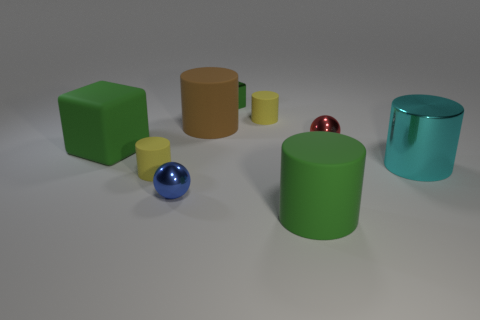Subtract all brown matte cylinders. How many cylinders are left? 4 Subtract all cyan cylinders. How many cylinders are left? 4 Subtract all red cylinders. Subtract all green cubes. How many cylinders are left? 5 Add 1 small blue rubber balls. How many objects exist? 10 Subtract all balls. How many objects are left? 7 Add 2 large green rubber cylinders. How many large green rubber cylinders are left? 3 Add 4 small brown matte objects. How many small brown matte objects exist? 4 Subtract 0 yellow spheres. How many objects are left? 9 Subtract all large purple spheres. Subtract all blue balls. How many objects are left? 8 